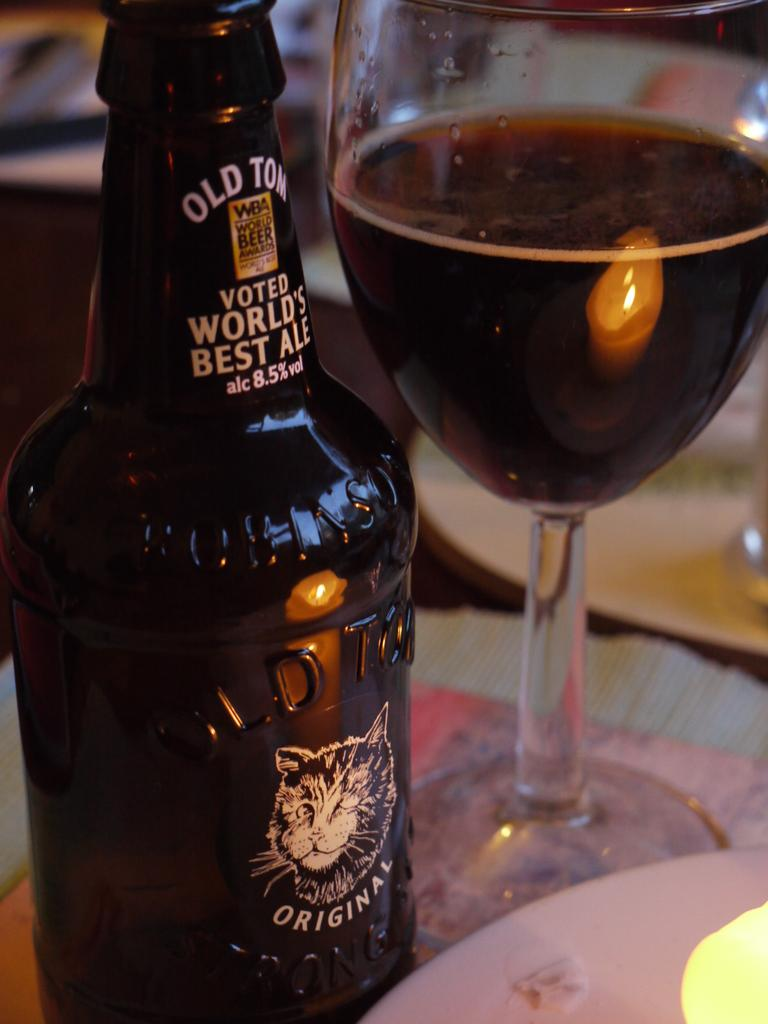<image>
Render a clear and concise summary of the photo. Old Tom voted World's Best Ale beer bottle with half glass of beer next to bottle. 